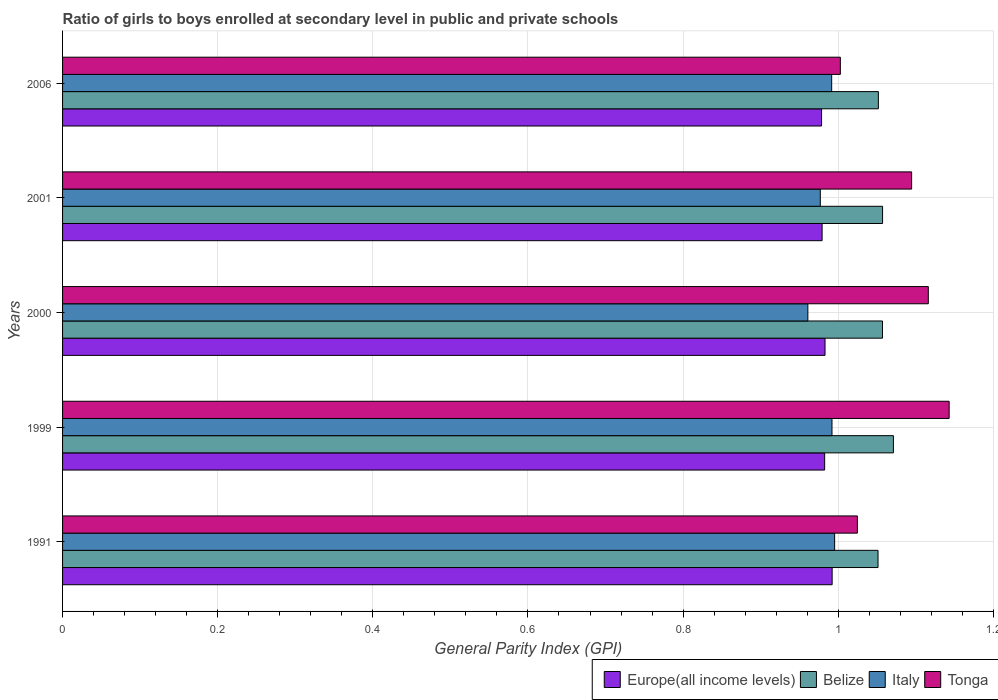How many groups of bars are there?
Provide a succinct answer. 5. Are the number of bars on each tick of the Y-axis equal?
Offer a very short reply. Yes. How many bars are there on the 5th tick from the top?
Keep it short and to the point. 4. How many bars are there on the 1st tick from the bottom?
Offer a very short reply. 4. What is the general parity index in Italy in 2006?
Provide a short and direct response. 0.99. Across all years, what is the maximum general parity index in Italy?
Offer a terse response. 1. Across all years, what is the minimum general parity index in Belize?
Offer a terse response. 1.05. In which year was the general parity index in Italy maximum?
Your answer should be very brief. 1991. In which year was the general parity index in Europe(all income levels) minimum?
Your answer should be compact. 2006. What is the total general parity index in Europe(all income levels) in the graph?
Make the answer very short. 4.92. What is the difference between the general parity index in Italy in 2001 and that in 2006?
Make the answer very short. -0.01. What is the difference between the general parity index in Europe(all income levels) in 2000 and the general parity index in Tonga in 1991?
Provide a short and direct response. -0.04. What is the average general parity index in Europe(all income levels) per year?
Keep it short and to the point. 0.98. In the year 2006, what is the difference between the general parity index in Belize and general parity index in Tonga?
Provide a succinct answer. 0.05. What is the ratio of the general parity index in Europe(all income levels) in 2000 to that in 2006?
Ensure brevity in your answer.  1. Is the general parity index in Tonga in 2000 less than that in 2001?
Provide a succinct answer. No. What is the difference between the highest and the second highest general parity index in Italy?
Make the answer very short. 0. What is the difference between the highest and the lowest general parity index in Belize?
Provide a succinct answer. 0.02. Is the sum of the general parity index in Italy in 1999 and 2001 greater than the maximum general parity index in Europe(all income levels) across all years?
Provide a short and direct response. Yes. What does the 2nd bar from the top in 2001 represents?
Provide a succinct answer. Italy. What does the 1st bar from the bottom in 1991 represents?
Your response must be concise. Europe(all income levels). Is it the case that in every year, the sum of the general parity index in Italy and general parity index in Europe(all income levels) is greater than the general parity index in Belize?
Provide a succinct answer. Yes. Are all the bars in the graph horizontal?
Your answer should be very brief. Yes. What is the difference between two consecutive major ticks on the X-axis?
Provide a short and direct response. 0.2. Does the graph contain any zero values?
Your response must be concise. No. Does the graph contain grids?
Provide a short and direct response. Yes. Where does the legend appear in the graph?
Offer a very short reply. Bottom right. How many legend labels are there?
Offer a terse response. 4. How are the legend labels stacked?
Give a very brief answer. Horizontal. What is the title of the graph?
Your response must be concise. Ratio of girls to boys enrolled at secondary level in public and private schools. Does "South Sudan" appear as one of the legend labels in the graph?
Keep it short and to the point. No. What is the label or title of the X-axis?
Keep it short and to the point. General Parity Index (GPI). What is the General Parity Index (GPI) of Europe(all income levels) in 1991?
Provide a short and direct response. 0.99. What is the General Parity Index (GPI) of Belize in 1991?
Provide a succinct answer. 1.05. What is the General Parity Index (GPI) in Italy in 1991?
Give a very brief answer. 1. What is the General Parity Index (GPI) in Tonga in 1991?
Your answer should be very brief. 1.02. What is the General Parity Index (GPI) in Europe(all income levels) in 1999?
Your response must be concise. 0.98. What is the General Parity Index (GPI) of Belize in 1999?
Offer a terse response. 1.07. What is the General Parity Index (GPI) in Italy in 1999?
Keep it short and to the point. 0.99. What is the General Parity Index (GPI) of Tonga in 1999?
Make the answer very short. 1.14. What is the General Parity Index (GPI) in Europe(all income levels) in 2000?
Keep it short and to the point. 0.98. What is the General Parity Index (GPI) in Belize in 2000?
Your answer should be compact. 1.06. What is the General Parity Index (GPI) of Italy in 2000?
Give a very brief answer. 0.96. What is the General Parity Index (GPI) of Tonga in 2000?
Your response must be concise. 1.12. What is the General Parity Index (GPI) of Europe(all income levels) in 2001?
Provide a succinct answer. 0.98. What is the General Parity Index (GPI) of Belize in 2001?
Give a very brief answer. 1.06. What is the General Parity Index (GPI) of Italy in 2001?
Give a very brief answer. 0.98. What is the General Parity Index (GPI) in Tonga in 2001?
Offer a terse response. 1.09. What is the General Parity Index (GPI) in Europe(all income levels) in 2006?
Give a very brief answer. 0.98. What is the General Parity Index (GPI) of Belize in 2006?
Keep it short and to the point. 1.05. What is the General Parity Index (GPI) of Italy in 2006?
Offer a terse response. 0.99. What is the General Parity Index (GPI) of Tonga in 2006?
Offer a terse response. 1. Across all years, what is the maximum General Parity Index (GPI) in Europe(all income levels)?
Your answer should be compact. 0.99. Across all years, what is the maximum General Parity Index (GPI) of Belize?
Offer a terse response. 1.07. Across all years, what is the maximum General Parity Index (GPI) of Italy?
Your answer should be very brief. 1. Across all years, what is the maximum General Parity Index (GPI) of Tonga?
Offer a terse response. 1.14. Across all years, what is the minimum General Parity Index (GPI) of Europe(all income levels)?
Offer a very short reply. 0.98. Across all years, what is the minimum General Parity Index (GPI) of Belize?
Give a very brief answer. 1.05. Across all years, what is the minimum General Parity Index (GPI) in Italy?
Make the answer very short. 0.96. Across all years, what is the minimum General Parity Index (GPI) in Tonga?
Give a very brief answer. 1. What is the total General Parity Index (GPI) in Europe(all income levels) in the graph?
Provide a short and direct response. 4.92. What is the total General Parity Index (GPI) of Belize in the graph?
Ensure brevity in your answer.  5.29. What is the total General Parity Index (GPI) of Italy in the graph?
Provide a succinct answer. 4.92. What is the total General Parity Index (GPI) of Tonga in the graph?
Keep it short and to the point. 5.38. What is the difference between the General Parity Index (GPI) of Europe(all income levels) in 1991 and that in 1999?
Ensure brevity in your answer.  0.01. What is the difference between the General Parity Index (GPI) of Belize in 1991 and that in 1999?
Make the answer very short. -0.02. What is the difference between the General Parity Index (GPI) in Italy in 1991 and that in 1999?
Your answer should be compact. 0. What is the difference between the General Parity Index (GPI) of Tonga in 1991 and that in 1999?
Offer a terse response. -0.12. What is the difference between the General Parity Index (GPI) in Europe(all income levels) in 1991 and that in 2000?
Your answer should be very brief. 0.01. What is the difference between the General Parity Index (GPI) of Belize in 1991 and that in 2000?
Make the answer very short. -0.01. What is the difference between the General Parity Index (GPI) of Italy in 1991 and that in 2000?
Your answer should be very brief. 0.03. What is the difference between the General Parity Index (GPI) of Tonga in 1991 and that in 2000?
Make the answer very short. -0.09. What is the difference between the General Parity Index (GPI) in Europe(all income levels) in 1991 and that in 2001?
Provide a short and direct response. 0.01. What is the difference between the General Parity Index (GPI) of Belize in 1991 and that in 2001?
Provide a short and direct response. -0.01. What is the difference between the General Parity Index (GPI) of Italy in 1991 and that in 2001?
Make the answer very short. 0.02. What is the difference between the General Parity Index (GPI) of Tonga in 1991 and that in 2001?
Provide a succinct answer. -0.07. What is the difference between the General Parity Index (GPI) of Europe(all income levels) in 1991 and that in 2006?
Offer a very short reply. 0.01. What is the difference between the General Parity Index (GPI) of Belize in 1991 and that in 2006?
Provide a succinct answer. -0. What is the difference between the General Parity Index (GPI) in Italy in 1991 and that in 2006?
Offer a terse response. 0. What is the difference between the General Parity Index (GPI) of Tonga in 1991 and that in 2006?
Provide a succinct answer. 0.02. What is the difference between the General Parity Index (GPI) in Europe(all income levels) in 1999 and that in 2000?
Offer a very short reply. -0. What is the difference between the General Parity Index (GPI) of Belize in 1999 and that in 2000?
Provide a short and direct response. 0.01. What is the difference between the General Parity Index (GPI) in Italy in 1999 and that in 2000?
Offer a terse response. 0.03. What is the difference between the General Parity Index (GPI) of Tonga in 1999 and that in 2000?
Your answer should be compact. 0.03. What is the difference between the General Parity Index (GPI) of Europe(all income levels) in 1999 and that in 2001?
Provide a short and direct response. 0. What is the difference between the General Parity Index (GPI) in Belize in 1999 and that in 2001?
Provide a short and direct response. 0.01. What is the difference between the General Parity Index (GPI) of Italy in 1999 and that in 2001?
Offer a very short reply. 0.02. What is the difference between the General Parity Index (GPI) in Tonga in 1999 and that in 2001?
Ensure brevity in your answer.  0.05. What is the difference between the General Parity Index (GPI) of Europe(all income levels) in 1999 and that in 2006?
Your response must be concise. 0. What is the difference between the General Parity Index (GPI) of Belize in 1999 and that in 2006?
Keep it short and to the point. 0.02. What is the difference between the General Parity Index (GPI) of Italy in 1999 and that in 2006?
Your answer should be very brief. 0. What is the difference between the General Parity Index (GPI) of Tonga in 1999 and that in 2006?
Keep it short and to the point. 0.14. What is the difference between the General Parity Index (GPI) in Europe(all income levels) in 2000 and that in 2001?
Keep it short and to the point. 0. What is the difference between the General Parity Index (GPI) in Belize in 2000 and that in 2001?
Your response must be concise. -0. What is the difference between the General Parity Index (GPI) in Italy in 2000 and that in 2001?
Give a very brief answer. -0.02. What is the difference between the General Parity Index (GPI) in Tonga in 2000 and that in 2001?
Provide a short and direct response. 0.02. What is the difference between the General Parity Index (GPI) in Europe(all income levels) in 2000 and that in 2006?
Provide a succinct answer. 0. What is the difference between the General Parity Index (GPI) in Belize in 2000 and that in 2006?
Your answer should be very brief. 0.01. What is the difference between the General Parity Index (GPI) of Italy in 2000 and that in 2006?
Your response must be concise. -0.03. What is the difference between the General Parity Index (GPI) in Tonga in 2000 and that in 2006?
Ensure brevity in your answer.  0.11. What is the difference between the General Parity Index (GPI) of Europe(all income levels) in 2001 and that in 2006?
Your response must be concise. 0. What is the difference between the General Parity Index (GPI) of Belize in 2001 and that in 2006?
Offer a terse response. 0.01. What is the difference between the General Parity Index (GPI) in Italy in 2001 and that in 2006?
Your response must be concise. -0.01. What is the difference between the General Parity Index (GPI) in Tonga in 2001 and that in 2006?
Give a very brief answer. 0.09. What is the difference between the General Parity Index (GPI) in Europe(all income levels) in 1991 and the General Parity Index (GPI) in Belize in 1999?
Provide a succinct answer. -0.08. What is the difference between the General Parity Index (GPI) in Europe(all income levels) in 1991 and the General Parity Index (GPI) in Tonga in 1999?
Provide a short and direct response. -0.15. What is the difference between the General Parity Index (GPI) of Belize in 1991 and the General Parity Index (GPI) of Italy in 1999?
Provide a succinct answer. 0.06. What is the difference between the General Parity Index (GPI) in Belize in 1991 and the General Parity Index (GPI) in Tonga in 1999?
Ensure brevity in your answer.  -0.09. What is the difference between the General Parity Index (GPI) in Italy in 1991 and the General Parity Index (GPI) in Tonga in 1999?
Provide a succinct answer. -0.15. What is the difference between the General Parity Index (GPI) in Europe(all income levels) in 1991 and the General Parity Index (GPI) in Belize in 2000?
Give a very brief answer. -0.06. What is the difference between the General Parity Index (GPI) in Europe(all income levels) in 1991 and the General Parity Index (GPI) in Italy in 2000?
Your answer should be compact. 0.03. What is the difference between the General Parity Index (GPI) of Europe(all income levels) in 1991 and the General Parity Index (GPI) of Tonga in 2000?
Provide a short and direct response. -0.12. What is the difference between the General Parity Index (GPI) of Belize in 1991 and the General Parity Index (GPI) of Italy in 2000?
Your answer should be compact. 0.09. What is the difference between the General Parity Index (GPI) in Belize in 1991 and the General Parity Index (GPI) in Tonga in 2000?
Make the answer very short. -0.06. What is the difference between the General Parity Index (GPI) in Italy in 1991 and the General Parity Index (GPI) in Tonga in 2000?
Ensure brevity in your answer.  -0.12. What is the difference between the General Parity Index (GPI) of Europe(all income levels) in 1991 and the General Parity Index (GPI) of Belize in 2001?
Your answer should be very brief. -0.07. What is the difference between the General Parity Index (GPI) of Europe(all income levels) in 1991 and the General Parity Index (GPI) of Italy in 2001?
Offer a very short reply. 0.02. What is the difference between the General Parity Index (GPI) in Europe(all income levels) in 1991 and the General Parity Index (GPI) in Tonga in 2001?
Give a very brief answer. -0.1. What is the difference between the General Parity Index (GPI) in Belize in 1991 and the General Parity Index (GPI) in Italy in 2001?
Offer a terse response. 0.07. What is the difference between the General Parity Index (GPI) of Belize in 1991 and the General Parity Index (GPI) of Tonga in 2001?
Offer a terse response. -0.04. What is the difference between the General Parity Index (GPI) of Italy in 1991 and the General Parity Index (GPI) of Tonga in 2001?
Offer a very short reply. -0.1. What is the difference between the General Parity Index (GPI) of Europe(all income levels) in 1991 and the General Parity Index (GPI) of Belize in 2006?
Your response must be concise. -0.06. What is the difference between the General Parity Index (GPI) of Europe(all income levels) in 1991 and the General Parity Index (GPI) of Italy in 2006?
Your response must be concise. 0. What is the difference between the General Parity Index (GPI) in Europe(all income levels) in 1991 and the General Parity Index (GPI) in Tonga in 2006?
Give a very brief answer. -0.01. What is the difference between the General Parity Index (GPI) in Belize in 1991 and the General Parity Index (GPI) in Italy in 2006?
Provide a succinct answer. 0.06. What is the difference between the General Parity Index (GPI) of Belize in 1991 and the General Parity Index (GPI) of Tonga in 2006?
Give a very brief answer. 0.05. What is the difference between the General Parity Index (GPI) in Italy in 1991 and the General Parity Index (GPI) in Tonga in 2006?
Provide a short and direct response. -0.01. What is the difference between the General Parity Index (GPI) of Europe(all income levels) in 1999 and the General Parity Index (GPI) of Belize in 2000?
Ensure brevity in your answer.  -0.07. What is the difference between the General Parity Index (GPI) in Europe(all income levels) in 1999 and the General Parity Index (GPI) in Italy in 2000?
Give a very brief answer. 0.02. What is the difference between the General Parity Index (GPI) in Europe(all income levels) in 1999 and the General Parity Index (GPI) in Tonga in 2000?
Offer a very short reply. -0.13. What is the difference between the General Parity Index (GPI) in Belize in 1999 and the General Parity Index (GPI) in Italy in 2000?
Your response must be concise. 0.11. What is the difference between the General Parity Index (GPI) in Belize in 1999 and the General Parity Index (GPI) in Tonga in 2000?
Offer a very short reply. -0.04. What is the difference between the General Parity Index (GPI) in Italy in 1999 and the General Parity Index (GPI) in Tonga in 2000?
Keep it short and to the point. -0.12. What is the difference between the General Parity Index (GPI) of Europe(all income levels) in 1999 and the General Parity Index (GPI) of Belize in 2001?
Make the answer very short. -0.07. What is the difference between the General Parity Index (GPI) in Europe(all income levels) in 1999 and the General Parity Index (GPI) in Italy in 2001?
Make the answer very short. 0.01. What is the difference between the General Parity Index (GPI) in Europe(all income levels) in 1999 and the General Parity Index (GPI) in Tonga in 2001?
Offer a very short reply. -0.11. What is the difference between the General Parity Index (GPI) in Belize in 1999 and the General Parity Index (GPI) in Italy in 2001?
Your answer should be compact. 0.09. What is the difference between the General Parity Index (GPI) of Belize in 1999 and the General Parity Index (GPI) of Tonga in 2001?
Provide a succinct answer. -0.02. What is the difference between the General Parity Index (GPI) in Italy in 1999 and the General Parity Index (GPI) in Tonga in 2001?
Offer a very short reply. -0.1. What is the difference between the General Parity Index (GPI) of Europe(all income levels) in 1999 and the General Parity Index (GPI) of Belize in 2006?
Offer a terse response. -0.07. What is the difference between the General Parity Index (GPI) in Europe(all income levels) in 1999 and the General Parity Index (GPI) in Italy in 2006?
Offer a very short reply. -0.01. What is the difference between the General Parity Index (GPI) in Europe(all income levels) in 1999 and the General Parity Index (GPI) in Tonga in 2006?
Provide a short and direct response. -0.02. What is the difference between the General Parity Index (GPI) of Belize in 1999 and the General Parity Index (GPI) of Italy in 2006?
Offer a terse response. 0.08. What is the difference between the General Parity Index (GPI) in Belize in 1999 and the General Parity Index (GPI) in Tonga in 2006?
Your answer should be compact. 0.07. What is the difference between the General Parity Index (GPI) in Italy in 1999 and the General Parity Index (GPI) in Tonga in 2006?
Your answer should be compact. -0.01. What is the difference between the General Parity Index (GPI) of Europe(all income levels) in 2000 and the General Parity Index (GPI) of Belize in 2001?
Make the answer very short. -0.07. What is the difference between the General Parity Index (GPI) of Europe(all income levels) in 2000 and the General Parity Index (GPI) of Italy in 2001?
Provide a short and direct response. 0.01. What is the difference between the General Parity Index (GPI) of Europe(all income levels) in 2000 and the General Parity Index (GPI) of Tonga in 2001?
Your answer should be compact. -0.11. What is the difference between the General Parity Index (GPI) of Belize in 2000 and the General Parity Index (GPI) of Italy in 2001?
Give a very brief answer. 0.08. What is the difference between the General Parity Index (GPI) in Belize in 2000 and the General Parity Index (GPI) in Tonga in 2001?
Ensure brevity in your answer.  -0.04. What is the difference between the General Parity Index (GPI) of Italy in 2000 and the General Parity Index (GPI) of Tonga in 2001?
Keep it short and to the point. -0.13. What is the difference between the General Parity Index (GPI) in Europe(all income levels) in 2000 and the General Parity Index (GPI) in Belize in 2006?
Provide a succinct answer. -0.07. What is the difference between the General Parity Index (GPI) of Europe(all income levels) in 2000 and the General Parity Index (GPI) of Italy in 2006?
Your answer should be compact. -0.01. What is the difference between the General Parity Index (GPI) in Europe(all income levels) in 2000 and the General Parity Index (GPI) in Tonga in 2006?
Your answer should be very brief. -0.02. What is the difference between the General Parity Index (GPI) of Belize in 2000 and the General Parity Index (GPI) of Italy in 2006?
Your response must be concise. 0.07. What is the difference between the General Parity Index (GPI) in Belize in 2000 and the General Parity Index (GPI) in Tonga in 2006?
Your answer should be compact. 0.05. What is the difference between the General Parity Index (GPI) in Italy in 2000 and the General Parity Index (GPI) in Tonga in 2006?
Your answer should be compact. -0.04. What is the difference between the General Parity Index (GPI) of Europe(all income levels) in 2001 and the General Parity Index (GPI) of Belize in 2006?
Offer a very short reply. -0.07. What is the difference between the General Parity Index (GPI) in Europe(all income levels) in 2001 and the General Parity Index (GPI) in Italy in 2006?
Offer a very short reply. -0.01. What is the difference between the General Parity Index (GPI) in Europe(all income levels) in 2001 and the General Parity Index (GPI) in Tonga in 2006?
Your answer should be very brief. -0.02. What is the difference between the General Parity Index (GPI) in Belize in 2001 and the General Parity Index (GPI) in Italy in 2006?
Your answer should be very brief. 0.07. What is the difference between the General Parity Index (GPI) in Belize in 2001 and the General Parity Index (GPI) in Tonga in 2006?
Offer a terse response. 0.05. What is the difference between the General Parity Index (GPI) in Italy in 2001 and the General Parity Index (GPI) in Tonga in 2006?
Offer a terse response. -0.03. What is the average General Parity Index (GPI) in Europe(all income levels) per year?
Offer a very short reply. 0.98. What is the average General Parity Index (GPI) of Belize per year?
Ensure brevity in your answer.  1.06. What is the average General Parity Index (GPI) in Italy per year?
Your response must be concise. 0.98. What is the average General Parity Index (GPI) of Tonga per year?
Offer a terse response. 1.08. In the year 1991, what is the difference between the General Parity Index (GPI) in Europe(all income levels) and General Parity Index (GPI) in Belize?
Offer a very short reply. -0.06. In the year 1991, what is the difference between the General Parity Index (GPI) in Europe(all income levels) and General Parity Index (GPI) in Italy?
Offer a very short reply. -0. In the year 1991, what is the difference between the General Parity Index (GPI) in Europe(all income levels) and General Parity Index (GPI) in Tonga?
Your response must be concise. -0.03. In the year 1991, what is the difference between the General Parity Index (GPI) in Belize and General Parity Index (GPI) in Italy?
Your answer should be compact. 0.06. In the year 1991, what is the difference between the General Parity Index (GPI) in Belize and General Parity Index (GPI) in Tonga?
Give a very brief answer. 0.03. In the year 1991, what is the difference between the General Parity Index (GPI) in Italy and General Parity Index (GPI) in Tonga?
Offer a very short reply. -0.03. In the year 1999, what is the difference between the General Parity Index (GPI) in Europe(all income levels) and General Parity Index (GPI) in Belize?
Make the answer very short. -0.09. In the year 1999, what is the difference between the General Parity Index (GPI) in Europe(all income levels) and General Parity Index (GPI) in Italy?
Your response must be concise. -0.01. In the year 1999, what is the difference between the General Parity Index (GPI) of Europe(all income levels) and General Parity Index (GPI) of Tonga?
Make the answer very short. -0.16. In the year 1999, what is the difference between the General Parity Index (GPI) in Belize and General Parity Index (GPI) in Italy?
Offer a terse response. 0.08. In the year 1999, what is the difference between the General Parity Index (GPI) of Belize and General Parity Index (GPI) of Tonga?
Provide a short and direct response. -0.07. In the year 1999, what is the difference between the General Parity Index (GPI) in Italy and General Parity Index (GPI) in Tonga?
Offer a terse response. -0.15. In the year 2000, what is the difference between the General Parity Index (GPI) of Europe(all income levels) and General Parity Index (GPI) of Belize?
Offer a terse response. -0.07. In the year 2000, what is the difference between the General Parity Index (GPI) of Europe(all income levels) and General Parity Index (GPI) of Italy?
Your answer should be compact. 0.02. In the year 2000, what is the difference between the General Parity Index (GPI) in Europe(all income levels) and General Parity Index (GPI) in Tonga?
Your answer should be very brief. -0.13. In the year 2000, what is the difference between the General Parity Index (GPI) in Belize and General Parity Index (GPI) in Italy?
Offer a terse response. 0.1. In the year 2000, what is the difference between the General Parity Index (GPI) of Belize and General Parity Index (GPI) of Tonga?
Provide a short and direct response. -0.06. In the year 2000, what is the difference between the General Parity Index (GPI) in Italy and General Parity Index (GPI) in Tonga?
Offer a very short reply. -0.16. In the year 2001, what is the difference between the General Parity Index (GPI) of Europe(all income levels) and General Parity Index (GPI) of Belize?
Provide a short and direct response. -0.08. In the year 2001, what is the difference between the General Parity Index (GPI) in Europe(all income levels) and General Parity Index (GPI) in Italy?
Offer a terse response. 0. In the year 2001, what is the difference between the General Parity Index (GPI) of Europe(all income levels) and General Parity Index (GPI) of Tonga?
Ensure brevity in your answer.  -0.12. In the year 2001, what is the difference between the General Parity Index (GPI) of Belize and General Parity Index (GPI) of Italy?
Your answer should be compact. 0.08. In the year 2001, what is the difference between the General Parity Index (GPI) of Belize and General Parity Index (GPI) of Tonga?
Your answer should be very brief. -0.04. In the year 2001, what is the difference between the General Parity Index (GPI) of Italy and General Parity Index (GPI) of Tonga?
Make the answer very short. -0.12. In the year 2006, what is the difference between the General Parity Index (GPI) of Europe(all income levels) and General Parity Index (GPI) of Belize?
Provide a succinct answer. -0.07. In the year 2006, what is the difference between the General Parity Index (GPI) of Europe(all income levels) and General Parity Index (GPI) of Italy?
Your answer should be very brief. -0.01. In the year 2006, what is the difference between the General Parity Index (GPI) of Europe(all income levels) and General Parity Index (GPI) of Tonga?
Give a very brief answer. -0.02. In the year 2006, what is the difference between the General Parity Index (GPI) of Belize and General Parity Index (GPI) of Italy?
Provide a short and direct response. 0.06. In the year 2006, what is the difference between the General Parity Index (GPI) in Belize and General Parity Index (GPI) in Tonga?
Make the answer very short. 0.05. In the year 2006, what is the difference between the General Parity Index (GPI) in Italy and General Parity Index (GPI) in Tonga?
Your answer should be very brief. -0.01. What is the ratio of the General Parity Index (GPI) in Europe(all income levels) in 1991 to that in 1999?
Offer a very short reply. 1.01. What is the ratio of the General Parity Index (GPI) of Belize in 1991 to that in 1999?
Ensure brevity in your answer.  0.98. What is the ratio of the General Parity Index (GPI) in Tonga in 1991 to that in 1999?
Give a very brief answer. 0.9. What is the ratio of the General Parity Index (GPI) of Europe(all income levels) in 1991 to that in 2000?
Offer a very short reply. 1.01. What is the ratio of the General Parity Index (GPI) of Italy in 1991 to that in 2000?
Make the answer very short. 1.04. What is the ratio of the General Parity Index (GPI) of Tonga in 1991 to that in 2000?
Give a very brief answer. 0.92. What is the ratio of the General Parity Index (GPI) in Europe(all income levels) in 1991 to that in 2001?
Give a very brief answer. 1.01. What is the ratio of the General Parity Index (GPI) in Italy in 1991 to that in 2001?
Offer a very short reply. 1.02. What is the ratio of the General Parity Index (GPI) of Tonga in 1991 to that in 2001?
Your answer should be compact. 0.94. What is the ratio of the General Parity Index (GPI) of Europe(all income levels) in 1991 to that in 2006?
Ensure brevity in your answer.  1.01. What is the ratio of the General Parity Index (GPI) of Italy in 1991 to that in 2006?
Your answer should be very brief. 1. What is the ratio of the General Parity Index (GPI) of Tonga in 1991 to that in 2006?
Offer a very short reply. 1.02. What is the ratio of the General Parity Index (GPI) of Belize in 1999 to that in 2000?
Give a very brief answer. 1.01. What is the ratio of the General Parity Index (GPI) in Italy in 1999 to that in 2000?
Offer a terse response. 1.03. What is the ratio of the General Parity Index (GPI) of Tonga in 1999 to that in 2000?
Your response must be concise. 1.02. What is the ratio of the General Parity Index (GPI) of Europe(all income levels) in 1999 to that in 2001?
Your answer should be very brief. 1. What is the ratio of the General Parity Index (GPI) of Belize in 1999 to that in 2001?
Provide a short and direct response. 1.01. What is the ratio of the General Parity Index (GPI) of Italy in 1999 to that in 2001?
Keep it short and to the point. 1.02. What is the ratio of the General Parity Index (GPI) of Tonga in 1999 to that in 2001?
Provide a succinct answer. 1.04. What is the ratio of the General Parity Index (GPI) of Belize in 1999 to that in 2006?
Offer a terse response. 1.02. What is the ratio of the General Parity Index (GPI) in Tonga in 1999 to that in 2006?
Make the answer very short. 1.14. What is the ratio of the General Parity Index (GPI) of Belize in 2000 to that in 2001?
Provide a succinct answer. 1. What is the ratio of the General Parity Index (GPI) of Italy in 2000 to that in 2001?
Keep it short and to the point. 0.98. What is the ratio of the General Parity Index (GPI) of Tonga in 2000 to that in 2001?
Your answer should be compact. 1.02. What is the ratio of the General Parity Index (GPI) in Europe(all income levels) in 2000 to that in 2006?
Provide a short and direct response. 1. What is the ratio of the General Parity Index (GPI) of Belize in 2000 to that in 2006?
Your answer should be compact. 1. What is the ratio of the General Parity Index (GPI) in Italy in 2000 to that in 2006?
Give a very brief answer. 0.97. What is the ratio of the General Parity Index (GPI) of Tonga in 2000 to that in 2006?
Provide a short and direct response. 1.11. What is the ratio of the General Parity Index (GPI) of Europe(all income levels) in 2001 to that in 2006?
Your answer should be compact. 1. What is the ratio of the General Parity Index (GPI) of Belize in 2001 to that in 2006?
Offer a terse response. 1.01. What is the ratio of the General Parity Index (GPI) of Italy in 2001 to that in 2006?
Keep it short and to the point. 0.99. What is the ratio of the General Parity Index (GPI) of Tonga in 2001 to that in 2006?
Your answer should be compact. 1.09. What is the difference between the highest and the second highest General Parity Index (GPI) in Europe(all income levels)?
Give a very brief answer. 0.01. What is the difference between the highest and the second highest General Parity Index (GPI) of Belize?
Your response must be concise. 0.01. What is the difference between the highest and the second highest General Parity Index (GPI) in Italy?
Your answer should be compact. 0. What is the difference between the highest and the second highest General Parity Index (GPI) of Tonga?
Your response must be concise. 0.03. What is the difference between the highest and the lowest General Parity Index (GPI) of Europe(all income levels)?
Ensure brevity in your answer.  0.01. What is the difference between the highest and the lowest General Parity Index (GPI) in Belize?
Keep it short and to the point. 0.02. What is the difference between the highest and the lowest General Parity Index (GPI) of Italy?
Ensure brevity in your answer.  0.03. What is the difference between the highest and the lowest General Parity Index (GPI) of Tonga?
Give a very brief answer. 0.14. 